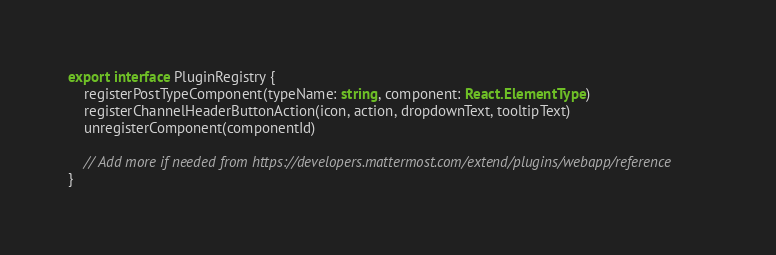<code> <loc_0><loc_0><loc_500><loc_500><_TypeScript_>export interface PluginRegistry {
    registerPostTypeComponent(typeName: string, component: React.ElementType)
    registerChannelHeaderButtonAction(icon, action, dropdownText, tooltipText)
    unregisterComponent(componentId)

    // Add more if needed from https://developers.mattermost.com/extend/plugins/webapp/reference
}
</code> 